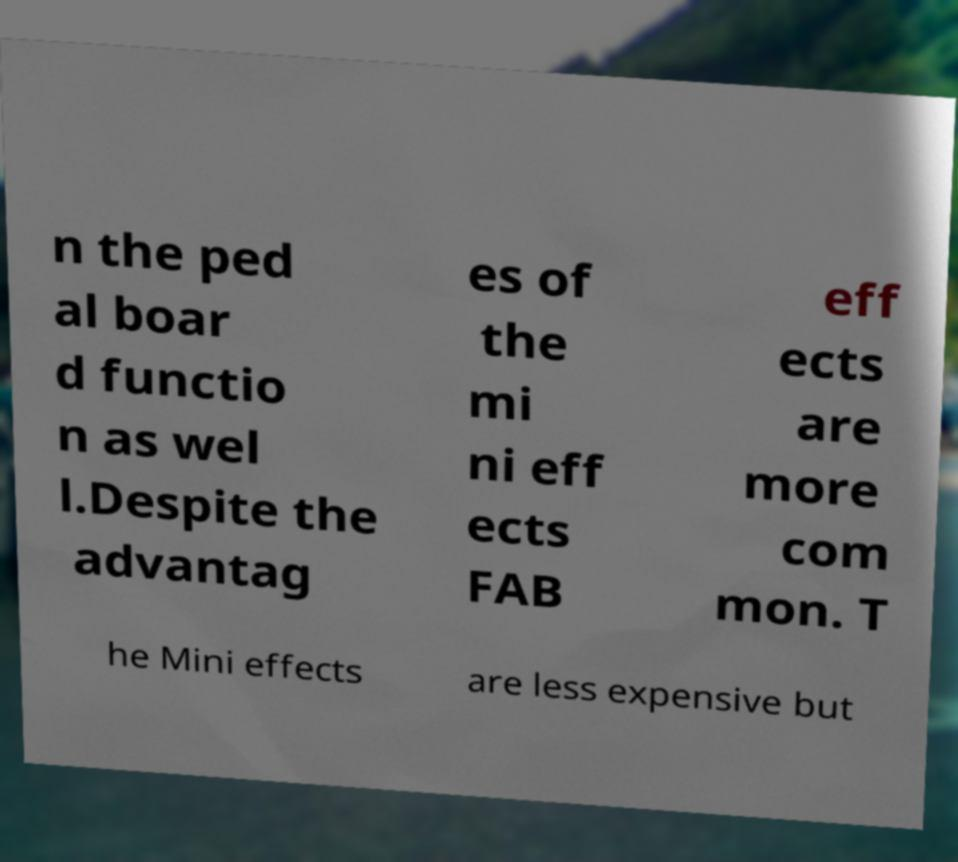Could you extract and type out the text from this image? n the ped al boar d functio n as wel l.Despite the advantag es of the mi ni eff ects FAB eff ects are more com mon. T he Mini effects are less expensive but 